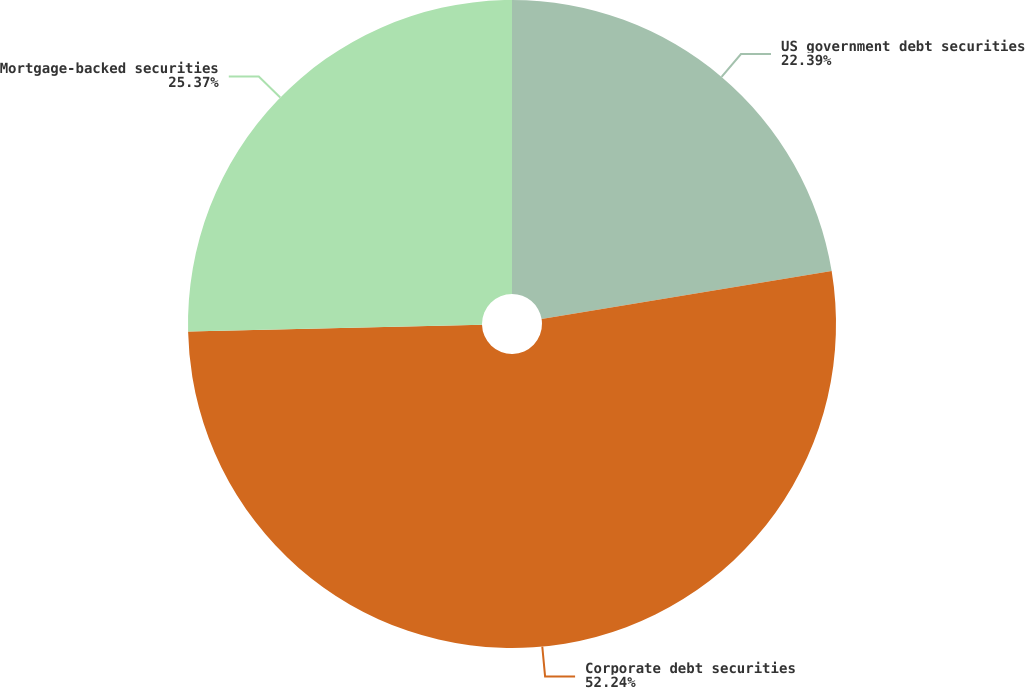<chart> <loc_0><loc_0><loc_500><loc_500><pie_chart><fcel>US government debt securities<fcel>Corporate debt securities<fcel>Mortgage-backed securities<nl><fcel>22.39%<fcel>52.24%<fcel>25.37%<nl></chart> 